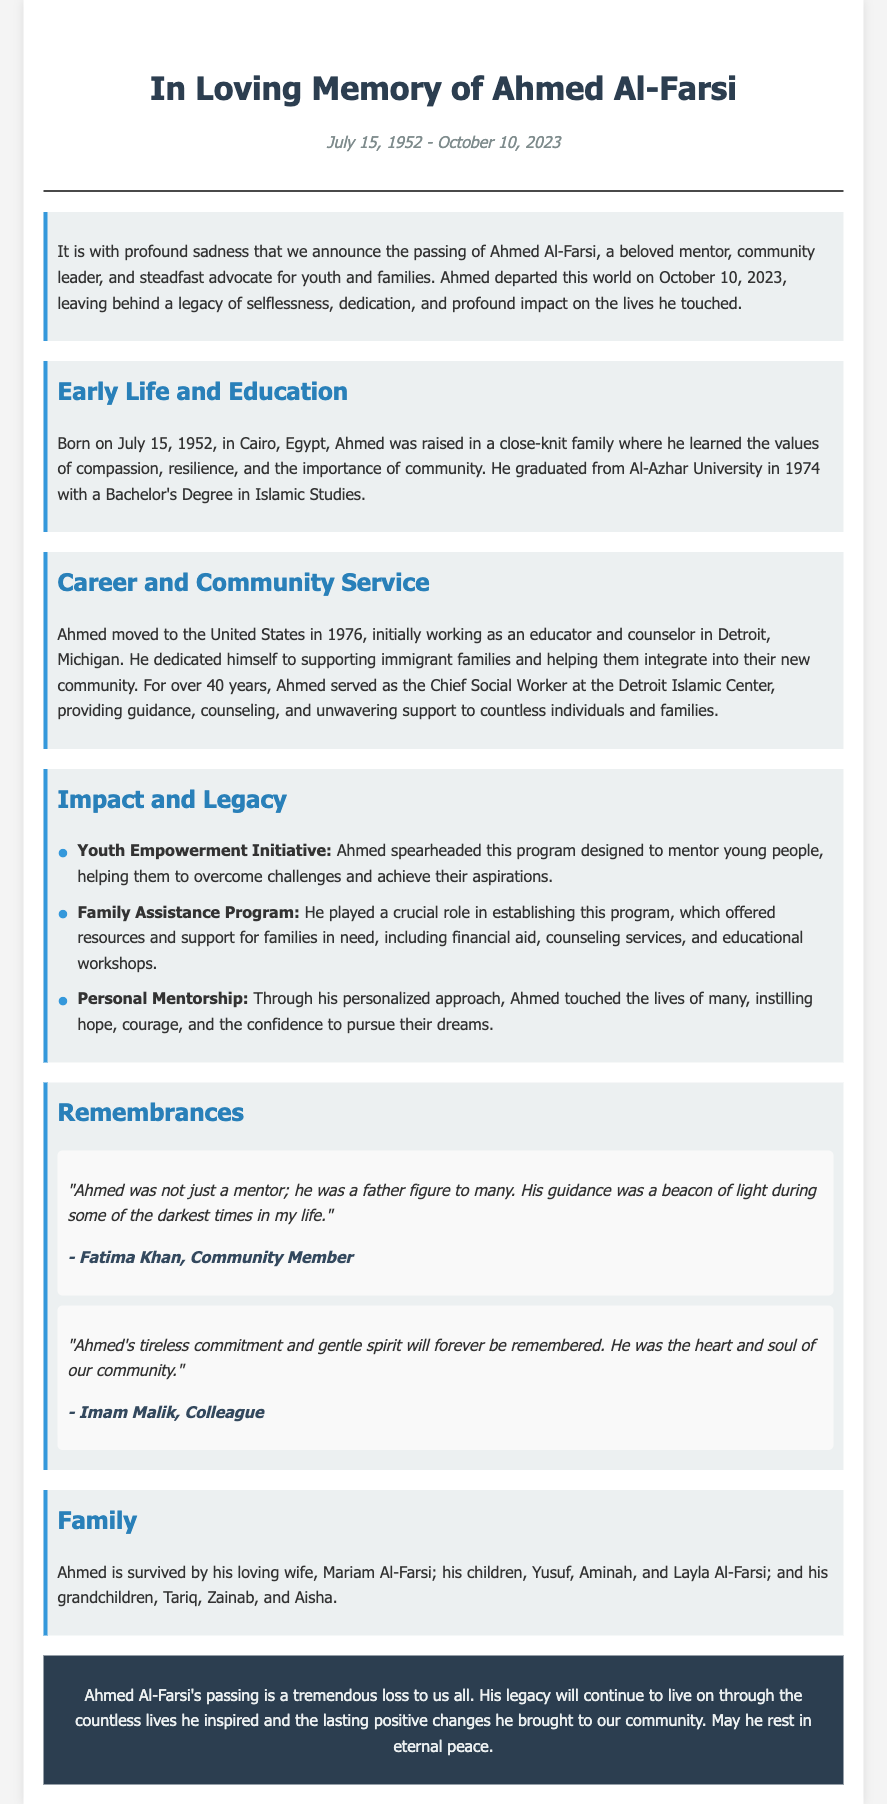What is the full name of the person honored in the obituary? The obituary honors Ahmed Al-Farsi, as mentioned in the title.
Answer: Ahmed Al-Farsi When was Ahmed Al-Farsi born? The document states that he was born on July 15, 1952.
Answer: July 15, 1952 What role did Ahmed serve at the Detroit Islamic Center? The document indicates that he served as the Chief Social Worker.
Answer: Chief Social Worker Which program was designed to empower youth? The document mentions the Youth Empowerment Initiative.
Answer: Youth Empowerment Initiative How many children did Ahmed Al-Farsi have? The obituary states he has three children: Yusuf, Aminah, and Layla.
Answer: Three What key value did Ahmed learn growing up in Cairo? The document highlights compassion as one of the key values learned.
Answer: Compassion What was the most notable impact of Ahmed's career? His career notably impacted youth and families through various programs he established.
Answer: Empowering youth and families Who referred to Ahmed as a father figure? Fatima Khan refers to Ahmed as a father figure in her testament.
Answer: Fatima Khan How long did Ahmed serve in his profession before passing? Ahmed served for over 40 years in his role before passing in 2023.
Answer: Over 40 years 